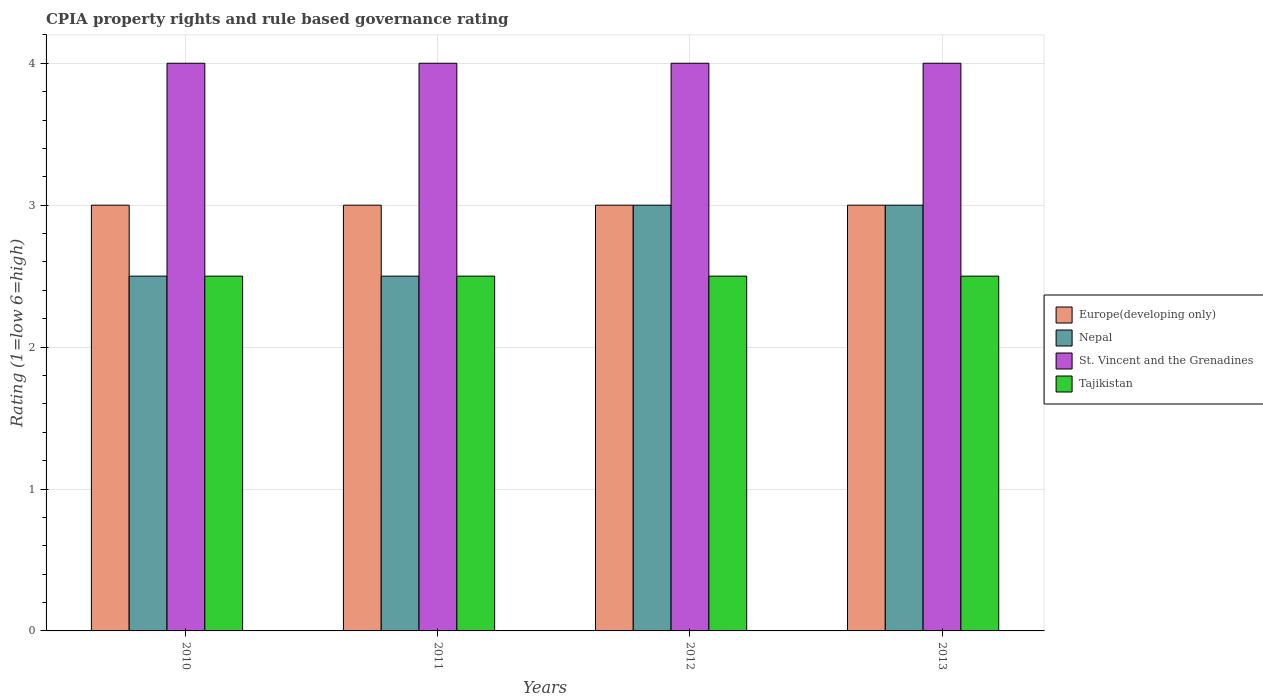How many bars are there on the 1st tick from the left?
Provide a succinct answer. 4. What is the label of the 1st group of bars from the left?
Make the answer very short. 2010. Across all years, what is the maximum CPIA rating in Nepal?
Your response must be concise. 3. What is the total CPIA rating in St. Vincent and the Grenadines in the graph?
Keep it short and to the point. 16. In the year 2013, what is the difference between the CPIA rating in Tajikistan and CPIA rating in Europe(developing only)?
Keep it short and to the point. -0.5. What is the ratio of the CPIA rating in Nepal in 2010 to that in 2013?
Provide a short and direct response. 0.83. Is the difference between the CPIA rating in Tajikistan in 2012 and 2013 greater than the difference between the CPIA rating in Europe(developing only) in 2012 and 2013?
Provide a short and direct response. No. What is the difference between the highest and the lowest CPIA rating in Nepal?
Offer a terse response. 0.5. In how many years, is the CPIA rating in Nepal greater than the average CPIA rating in Nepal taken over all years?
Provide a succinct answer. 2. Is the sum of the CPIA rating in Europe(developing only) in 2011 and 2013 greater than the maximum CPIA rating in Tajikistan across all years?
Make the answer very short. Yes. What does the 4th bar from the left in 2010 represents?
Provide a succinct answer. Tajikistan. What does the 4th bar from the right in 2010 represents?
Your response must be concise. Europe(developing only). Is it the case that in every year, the sum of the CPIA rating in Europe(developing only) and CPIA rating in Nepal is greater than the CPIA rating in Tajikistan?
Your response must be concise. Yes. What is the difference between two consecutive major ticks on the Y-axis?
Your answer should be very brief. 1. Are the values on the major ticks of Y-axis written in scientific E-notation?
Offer a terse response. No. Does the graph contain any zero values?
Ensure brevity in your answer.  No. Does the graph contain grids?
Keep it short and to the point. Yes. Where does the legend appear in the graph?
Your answer should be compact. Center right. How many legend labels are there?
Your answer should be very brief. 4. How are the legend labels stacked?
Make the answer very short. Vertical. What is the title of the graph?
Keep it short and to the point. CPIA property rights and rule based governance rating. What is the Rating (1=low 6=high) of St. Vincent and the Grenadines in 2010?
Your answer should be compact. 4. What is the Rating (1=low 6=high) of Europe(developing only) in 2011?
Offer a terse response. 3. What is the Rating (1=low 6=high) in Europe(developing only) in 2012?
Your response must be concise. 3. What is the Rating (1=low 6=high) of St. Vincent and the Grenadines in 2012?
Keep it short and to the point. 4. What is the Rating (1=low 6=high) of Nepal in 2013?
Provide a succinct answer. 3. What is the Rating (1=low 6=high) of St. Vincent and the Grenadines in 2013?
Keep it short and to the point. 4. What is the Rating (1=low 6=high) in Tajikistan in 2013?
Make the answer very short. 2.5. Across all years, what is the maximum Rating (1=low 6=high) in Tajikistan?
Your answer should be very brief. 2.5. Across all years, what is the minimum Rating (1=low 6=high) of Europe(developing only)?
Your response must be concise. 3. Across all years, what is the minimum Rating (1=low 6=high) in Nepal?
Make the answer very short. 2.5. Across all years, what is the minimum Rating (1=low 6=high) in Tajikistan?
Keep it short and to the point. 2.5. What is the total Rating (1=low 6=high) in Nepal in the graph?
Keep it short and to the point. 11. What is the total Rating (1=low 6=high) of St. Vincent and the Grenadines in the graph?
Your answer should be very brief. 16. What is the difference between the Rating (1=low 6=high) in Europe(developing only) in 2010 and that in 2011?
Keep it short and to the point. 0. What is the difference between the Rating (1=low 6=high) in Nepal in 2010 and that in 2011?
Your response must be concise. 0. What is the difference between the Rating (1=low 6=high) in St. Vincent and the Grenadines in 2010 and that in 2011?
Offer a very short reply. 0. What is the difference between the Rating (1=low 6=high) of Europe(developing only) in 2010 and that in 2012?
Offer a terse response. 0. What is the difference between the Rating (1=low 6=high) in Europe(developing only) in 2010 and that in 2013?
Your answer should be compact. 0. What is the difference between the Rating (1=low 6=high) in Nepal in 2010 and that in 2013?
Offer a very short reply. -0.5. What is the difference between the Rating (1=low 6=high) in Nepal in 2011 and that in 2012?
Make the answer very short. -0.5. What is the difference between the Rating (1=low 6=high) in Europe(developing only) in 2011 and that in 2013?
Offer a very short reply. 0. What is the difference between the Rating (1=low 6=high) of St. Vincent and the Grenadines in 2011 and that in 2013?
Make the answer very short. 0. What is the difference between the Rating (1=low 6=high) of St. Vincent and the Grenadines in 2012 and that in 2013?
Offer a very short reply. 0. What is the difference between the Rating (1=low 6=high) of Europe(developing only) in 2010 and the Rating (1=low 6=high) of Tajikistan in 2011?
Provide a short and direct response. 0.5. What is the difference between the Rating (1=low 6=high) in Nepal in 2010 and the Rating (1=low 6=high) in St. Vincent and the Grenadines in 2011?
Ensure brevity in your answer.  -1.5. What is the difference between the Rating (1=low 6=high) of Nepal in 2010 and the Rating (1=low 6=high) of Tajikistan in 2011?
Your answer should be compact. 0. What is the difference between the Rating (1=low 6=high) in Europe(developing only) in 2010 and the Rating (1=low 6=high) in Nepal in 2012?
Make the answer very short. 0. What is the difference between the Rating (1=low 6=high) in Europe(developing only) in 2010 and the Rating (1=low 6=high) in St. Vincent and the Grenadines in 2012?
Offer a terse response. -1. What is the difference between the Rating (1=low 6=high) in Europe(developing only) in 2010 and the Rating (1=low 6=high) in Tajikistan in 2012?
Make the answer very short. 0.5. What is the difference between the Rating (1=low 6=high) of Nepal in 2010 and the Rating (1=low 6=high) of St. Vincent and the Grenadines in 2012?
Ensure brevity in your answer.  -1.5. What is the difference between the Rating (1=low 6=high) of Nepal in 2010 and the Rating (1=low 6=high) of Tajikistan in 2012?
Your response must be concise. 0. What is the difference between the Rating (1=low 6=high) of Europe(developing only) in 2010 and the Rating (1=low 6=high) of St. Vincent and the Grenadines in 2013?
Keep it short and to the point. -1. What is the difference between the Rating (1=low 6=high) of Europe(developing only) in 2010 and the Rating (1=low 6=high) of Tajikistan in 2013?
Keep it short and to the point. 0.5. What is the difference between the Rating (1=low 6=high) of Nepal in 2010 and the Rating (1=low 6=high) of Tajikistan in 2013?
Your response must be concise. 0. What is the difference between the Rating (1=low 6=high) in St. Vincent and the Grenadines in 2010 and the Rating (1=low 6=high) in Tajikistan in 2013?
Your answer should be very brief. 1.5. What is the difference between the Rating (1=low 6=high) in Europe(developing only) in 2011 and the Rating (1=low 6=high) in St. Vincent and the Grenadines in 2012?
Your answer should be compact. -1. What is the difference between the Rating (1=low 6=high) in Europe(developing only) in 2011 and the Rating (1=low 6=high) in Tajikistan in 2012?
Your answer should be compact. 0.5. What is the difference between the Rating (1=low 6=high) in Nepal in 2011 and the Rating (1=low 6=high) in St. Vincent and the Grenadines in 2012?
Provide a short and direct response. -1.5. What is the difference between the Rating (1=low 6=high) of Europe(developing only) in 2011 and the Rating (1=low 6=high) of Nepal in 2013?
Give a very brief answer. 0. What is the difference between the Rating (1=low 6=high) of Europe(developing only) in 2011 and the Rating (1=low 6=high) of St. Vincent and the Grenadines in 2013?
Provide a short and direct response. -1. What is the difference between the Rating (1=low 6=high) in Nepal in 2011 and the Rating (1=low 6=high) in St. Vincent and the Grenadines in 2013?
Offer a terse response. -1.5. What is the difference between the Rating (1=low 6=high) in Nepal in 2011 and the Rating (1=low 6=high) in Tajikistan in 2013?
Your answer should be very brief. 0. What is the difference between the Rating (1=low 6=high) in St. Vincent and the Grenadines in 2011 and the Rating (1=low 6=high) in Tajikistan in 2013?
Provide a short and direct response. 1.5. What is the average Rating (1=low 6=high) in Europe(developing only) per year?
Offer a terse response. 3. What is the average Rating (1=low 6=high) of Nepal per year?
Ensure brevity in your answer.  2.75. What is the average Rating (1=low 6=high) of St. Vincent and the Grenadines per year?
Offer a very short reply. 4. In the year 2010, what is the difference between the Rating (1=low 6=high) in Europe(developing only) and Rating (1=low 6=high) in St. Vincent and the Grenadines?
Your answer should be very brief. -1. In the year 2011, what is the difference between the Rating (1=low 6=high) of Europe(developing only) and Rating (1=low 6=high) of St. Vincent and the Grenadines?
Your answer should be compact. -1. In the year 2012, what is the difference between the Rating (1=low 6=high) of Europe(developing only) and Rating (1=low 6=high) of Tajikistan?
Offer a terse response. 0.5. In the year 2012, what is the difference between the Rating (1=low 6=high) in Nepal and Rating (1=low 6=high) in St. Vincent and the Grenadines?
Your response must be concise. -1. In the year 2012, what is the difference between the Rating (1=low 6=high) of St. Vincent and the Grenadines and Rating (1=low 6=high) of Tajikistan?
Offer a very short reply. 1.5. In the year 2013, what is the difference between the Rating (1=low 6=high) of Nepal and Rating (1=low 6=high) of Tajikistan?
Provide a succinct answer. 0.5. What is the ratio of the Rating (1=low 6=high) in Europe(developing only) in 2010 to that in 2012?
Provide a succinct answer. 1. What is the ratio of the Rating (1=low 6=high) in St. Vincent and the Grenadines in 2010 to that in 2012?
Provide a succinct answer. 1. What is the ratio of the Rating (1=low 6=high) of St. Vincent and the Grenadines in 2010 to that in 2013?
Your answer should be very brief. 1. What is the ratio of the Rating (1=low 6=high) in Europe(developing only) in 2011 to that in 2012?
Make the answer very short. 1. What is the ratio of the Rating (1=low 6=high) of Nepal in 2011 to that in 2012?
Make the answer very short. 0.83. What is the ratio of the Rating (1=low 6=high) of Europe(developing only) in 2011 to that in 2013?
Your answer should be very brief. 1. What is the ratio of the Rating (1=low 6=high) in Nepal in 2011 to that in 2013?
Give a very brief answer. 0.83. What is the ratio of the Rating (1=low 6=high) in St. Vincent and the Grenadines in 2011 to that in 2013?
Your answer should be compact. 1. What is the ratio of the Rating (1=low 6=high) in Tajikistan in 2011 to that in 2013?
Offer a terse response. 1. What is the ratio of the Rating (1=low 6=high) in Europe(developing only) in 2012 to that in 2013?
Keep it short and to the point. 1. What is the ratio of the Rating (1=low 6=high) of Nepal in 2012 to that in 2013?
Provide a succinct answer. 1. What is the ratio of the Rating (1=low 6=high) of St. Vincent and the Grenadines in 2012 to that in 2013?
Ensure brevity in your answer.  1. What is the ratio of the Rating (1=low 6=high) in Tajikistan in 2012 to that in 2013?
Offer a very short reply. 1. What is the difference between the highest and the second highest Rating (1=low 6=high) in Europe(developing only)?
Offer a very short reply. 0. What is the difference between the highest and the second highest Rating (1=low 6=high) in Nepal?
Offer a very short reply. 0. What is the difference between the highest and the lowest Rating (1=low 6=high) of Nepal?
Ensure brevity in your answer.  0.5. What is the difference between the highest and the lowest Rating (1=low 6=high) of St. Vincent and the Grenadines?
Your answer should be compact. 0. What is the difference between the highest and the lowest Rating (1=low 6=high) in Tajikistan?
Give a very brief answer. 0. 